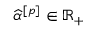<formula> <loc_0><loc_0><loc_500><loc_500>\widehat { \alpha } ^ { [ p ] } \in \mathbb { R } _ { + }</formula> 